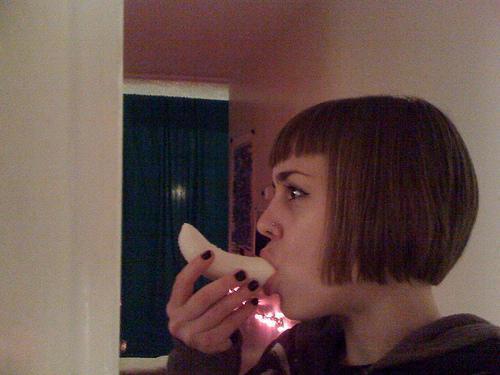How many people are in this photo?
Give a very brief answer. 1. 